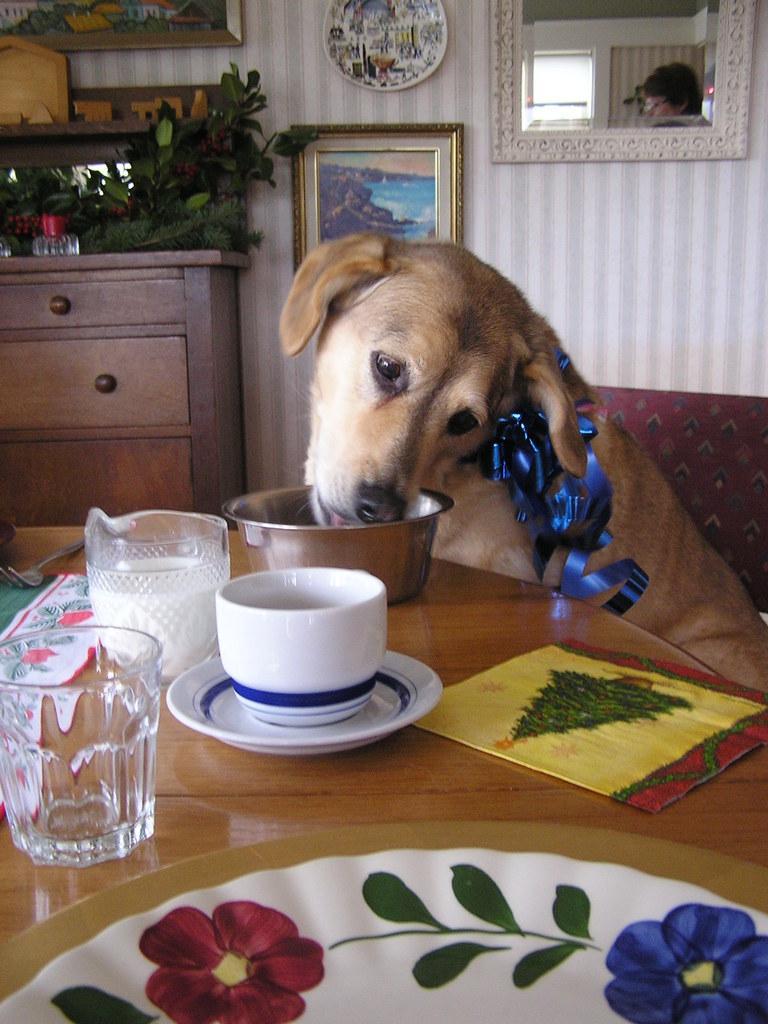Please provide a concise description of this image. This is an image clicked inside the room. Here I can see a dog. In front of this there is a table on which a bowl, cup, plate, spoon and a sheet are placed. In the background there is another table on which a plant and bottle are placed. Beside this there is a wall on which frames and mirror are attached. 